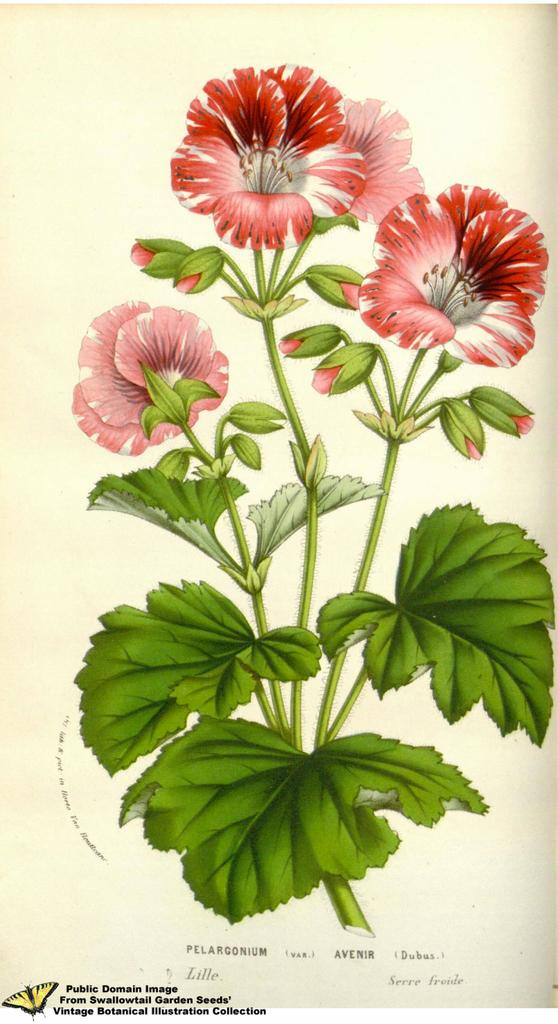What is the main subject of the painting in the image? The main subject of the painting in the image is flowers. Are there any other elements in the painting besides flowers? Yes, the painting includes leaves. Is there any text present in the image? Yes, there is text at the bottom of the image. What additional element can be seen in the painting? There is a butterfly depicted in the image. What type of war is being depicted in the image? There is no war depicted in the image; it features a painting of flowers, leaves, and a butterfly with text at the bottom. 